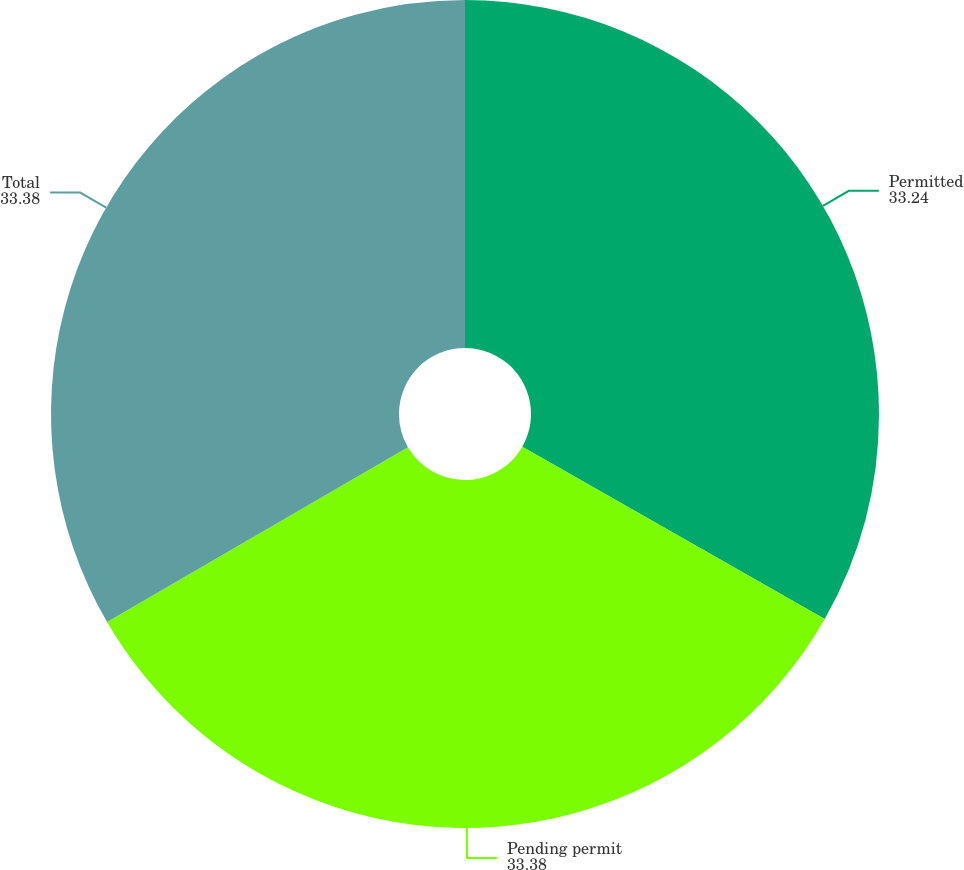Convert chart. <chart><loc_0><loc_0><loc_500><loc_500><pie_chart><fcel>Permitted<fcel>Pending permit<fcel>Total<nl><fcel>33.24%<fcel>33.38%<fcel>33.38%<nl></chart> 